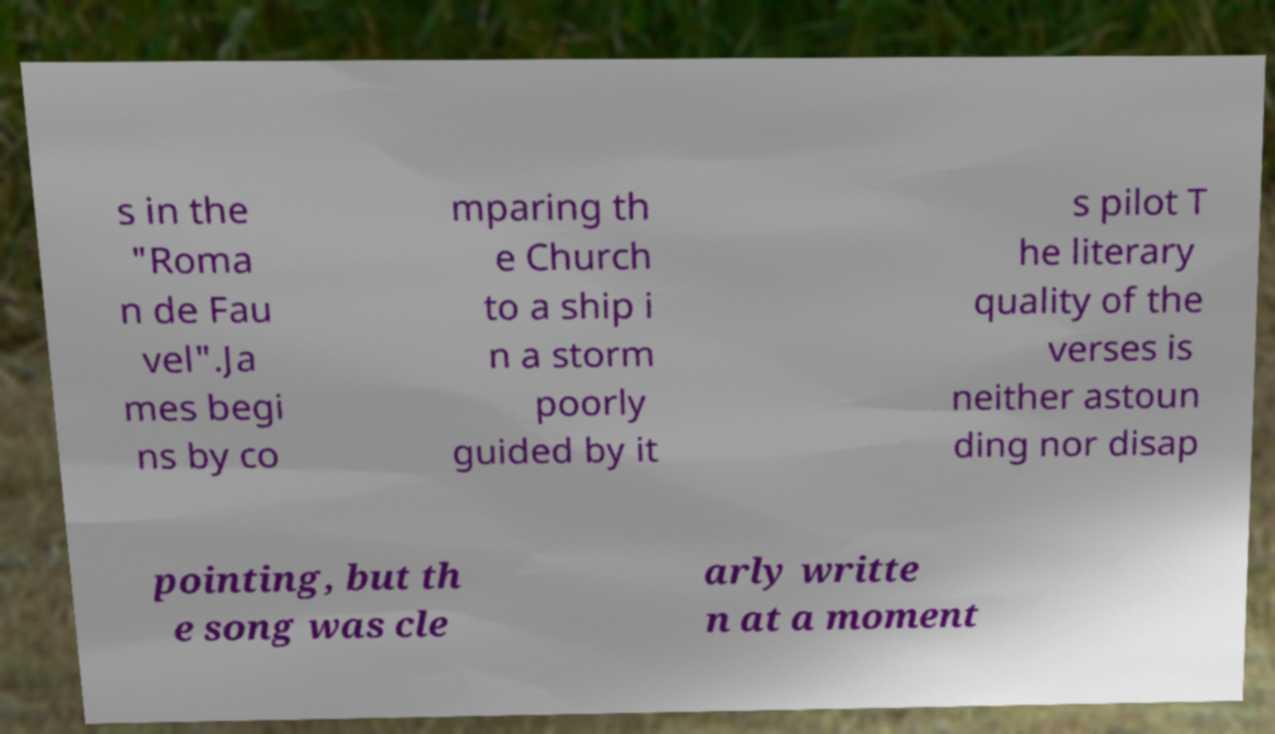What messages or text are displayed in this image? I need them in a readable, typed format. s in the "Roma n de Fau vel".Ja mes begi ns by co mparing th e Church to a ship i n a storm poorly guided by it s pilot T he literary quality of the verses is neither astoun ding nor disap pointing, but th e song was cle arly writte n at a moment 